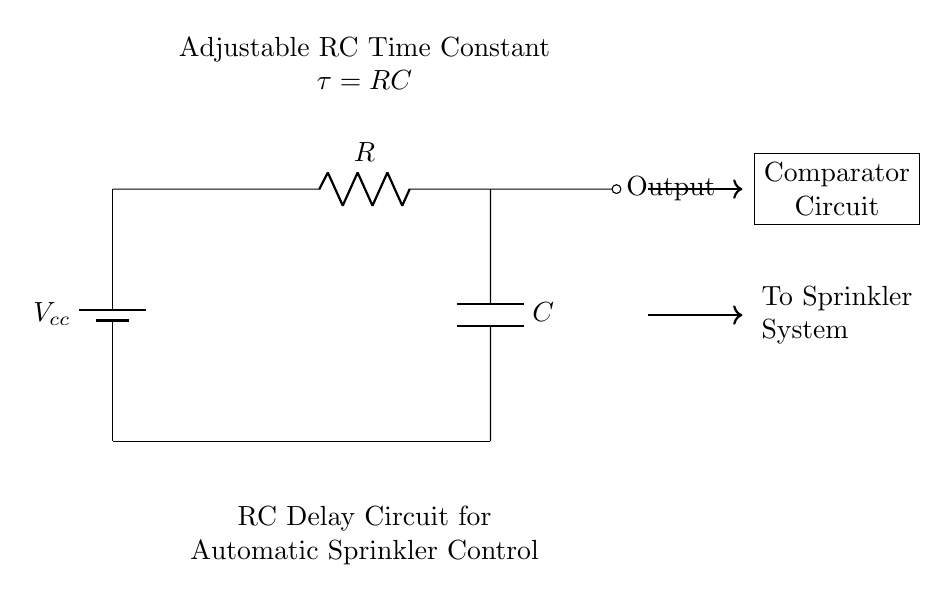What does the component labeled R represent? In the circuit, R indicates a resistor, which is used to limit current and create a voltage drop in the circuit.
Answer: Resistor What is the purpose of the capacitor in this circuit? The capacitor stores electrical energy and creates a time delay in charging and discharging, which is essential for controlling the automatic sprinkler timing.
Answer: Time delay What is the voltage supply shown in the circuit? The voltage supply is labeled as Vcc, representing the positive voltage supply needed to power the circuit components.
Answer: Vcc What is the relationship between the resistor and capacitor in this circuit? The relationship is described by the time constant formula, τ (tau) = R * C, where R is the resistance and C is the capacitance, determining how fast the circuit responds.
Answer: τ = RC Where does the output of this circuit go? The output is directed to the sprinkler system, as indicated by the connection labeled "To Sprinkler System."
Answer: Sprinkler System What does the comparator circuit do in this diagram? The comparator circuit compares the voltage levels to determine when to activate or deactivate the sprinkler system based on the output signal from the RC circuit.
Answer: Activates sprinklers 